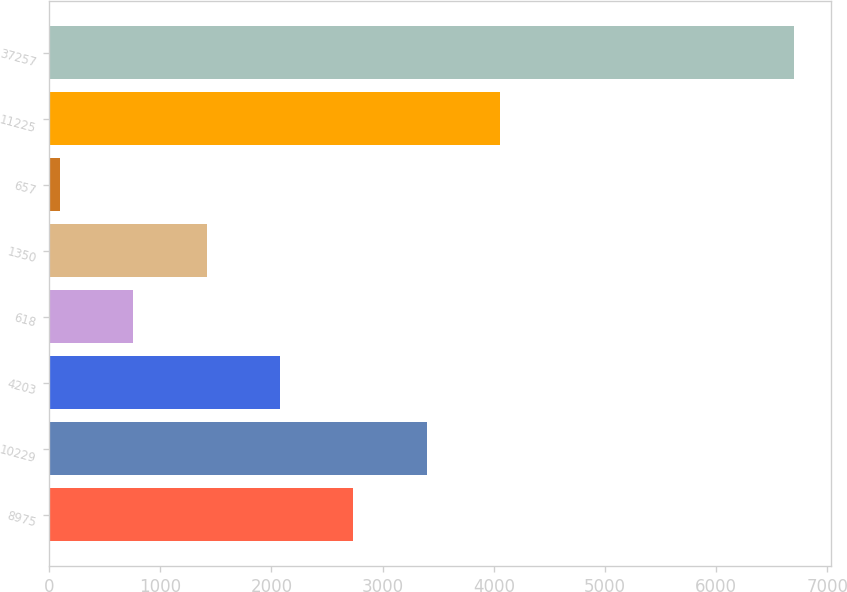Convert chart to OTSL. <chart><loc_0><loc_0><loc_500><loc_500><bar_chart><fcel>8975<fcel>10229<fcel>4203<fcel>618<fcel>1350<fcel>657<fcel>11225<fcel>37257<nl><fcel>2737.38<fcel>3397.8<fcel>2076.96<fcel>756.12<fcel>1416.54<fcel>95.7<fcel>4058.22<fcel>6699.9<nl></chart> 